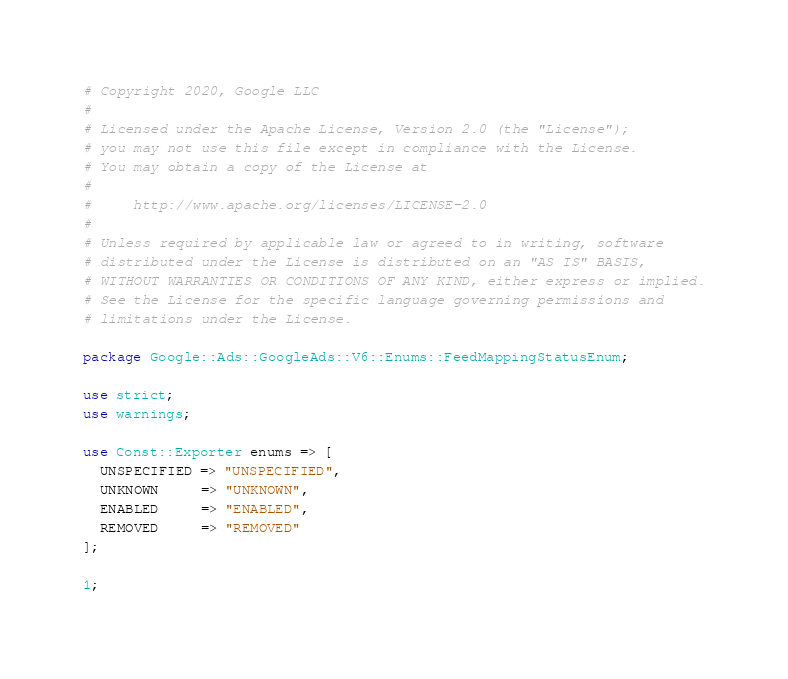<code> <loc_0><loc_0><loc_500><loc_500><_Perl_># Copyright 2020, Google LLC
#
# Licensed under the Apache License, Version 2.0 (the "License");
# you may not use this file except in compliance with the License.
# You may obtain a copy of the License at
#
#     http://www.apache.org/licenses/LICENSE-2.0
#
# Unless required by applicable law or agreed to in writing, software
# distributed under the License is distributed on an "AS IS" BASIS,
# WITHOUT WARRANTIES OR CONDITIONS OF ANY KIND, either express or implied.
# See the License for the specific language governing permissions and
# limitations under the License.

package Google::Ads::GoogleAds::V6::Enums::FeedMappingStatusEnum;

use strict;
use warnings;

use Const::Exporter enums => [
  UNSPECIFIED => "UNSPECIFIED",
  UNKNOWN     => "UNKNOWN",
  ENABLED     => "ENABLED",
  REMOVED     => "REMOVED"
];

1;
</code> 